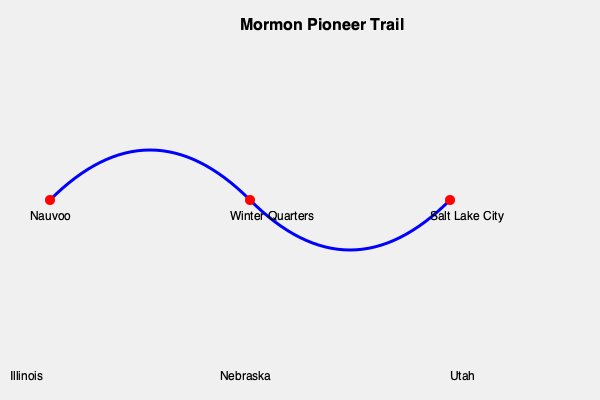Based on the map of the Mormon Pioneer Trail, what was the significance of Winter Quarters in the migration process, and how did its geographical location contribute to the success of the westward journey? 1. Location: Winter Quarters was situated approximately halfway between Nauvoo, Illinois, and Salt Lake City, Utah, as shown on the map.

2. Timing: The Mormons arrived at Winter Quarters in 1846, after being forced to leave Nauvoo.

3. Purpose: Winter Quarters served as a crucial stopover point for the Mormon pioneers during their westward migration.

4. Preparation: It allowed the pioneers to rest, regroup, and prepare for the challenging journey across the Great Plains and Rocky Mountains.

5. Community building: Approximately 12,000 Mormons established a temporary settlement at Winter Quarters.

6. Planning: Church leaders, including Brigham Young, used this time to plan the next stages of the migration and organize the pioneers into smaller groups.

7. Hardships: Many pioneers faced illness and death during their stay at Winter Quarters due to harsh conditions.

8. Spiritual significance: The Mormon pioneers received revelations and spiritual guidance at Winter Quarters, strengthening their resolve for the journey ahead.

9. Geographical advantage: Its location near the Missouri River provided access to water and potential trade routes.

10. Launching point: In April 1847, the first group of pioneers left Winter Quarters for the Salt Lake Valley, establishing the route for future migrations.
Answer: Winter Quarters was a crucial midpoint stopover that allowed for rest, preparation, and organization of the Mormon pioneers, significantly contributing to the successful completion of their westward migration to Salt Lake City. 